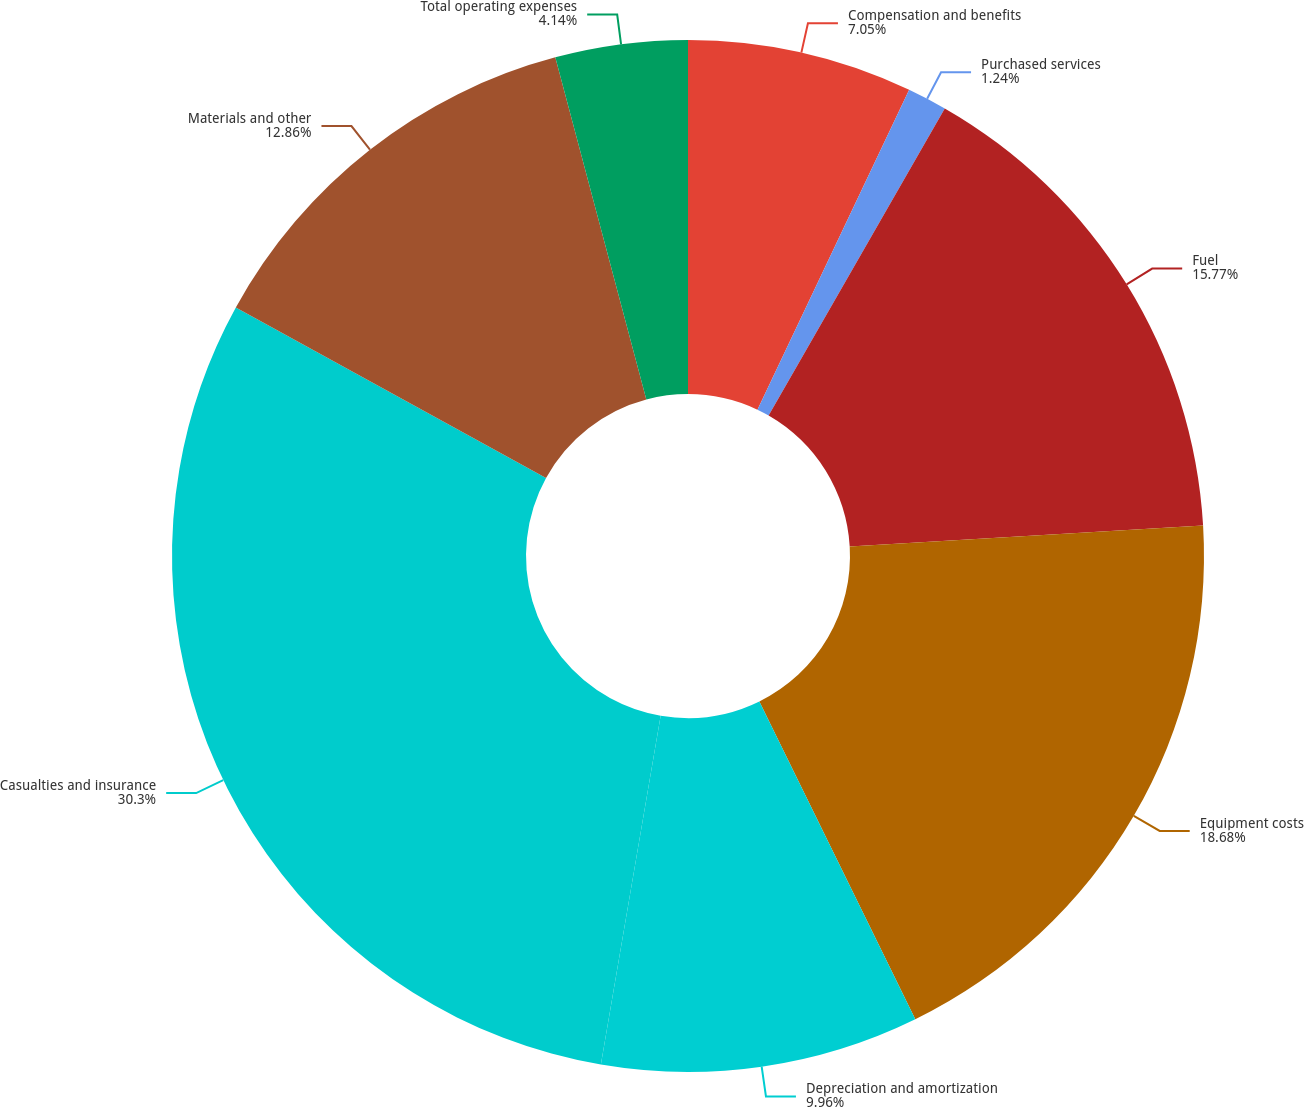Convert chart. <chart><loc_0><loc_0><loc_500><loc_500><pie_chart><fcel>Compensation and benefits<fcel>Purchased services<fcel>Fuel<fcel>Equipment costs<fcel>Depreciation and amortization<fcel>Casualties and insurance<fcel>Materials and other<fcel>Total operating expenses<nl><fcel>7.05%<fcel>1.24%<fcel>15.77%<fcel>18.68%<fcel>9.96%<fcel>30.3%<fcel>12.86%<fcel>4.14%<nl></chart> 